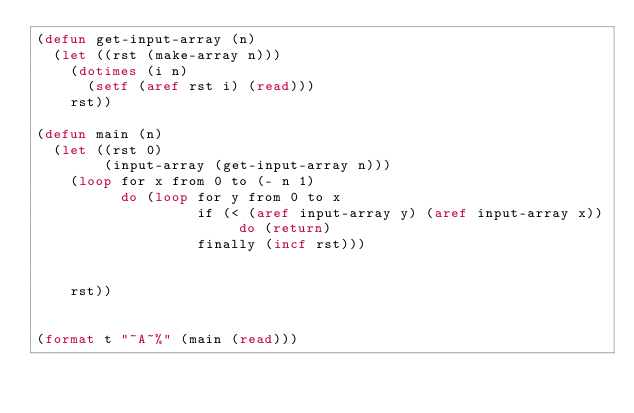<code> <loc_0><loc_0><loc_500><loc_500><_Lisp_>(defun get-input-array (n)
  (let ((rst (make-array n)))
    (dotimes (i n)
      (setf (aref rst i) (read)))
    rst))

(defun main (n)
  (let ((rst 0)
        (input-array (get-input-array n)))
    (loop for x from 0 to (- n 1)
          do (loop for y from 0 to x
                   if (< (aref input-array y) (aref input-array x)) do (return)
                   finally (incf rst)))
                   
          
    rst))


(format t "~A~%" (main (read)))
</code> 